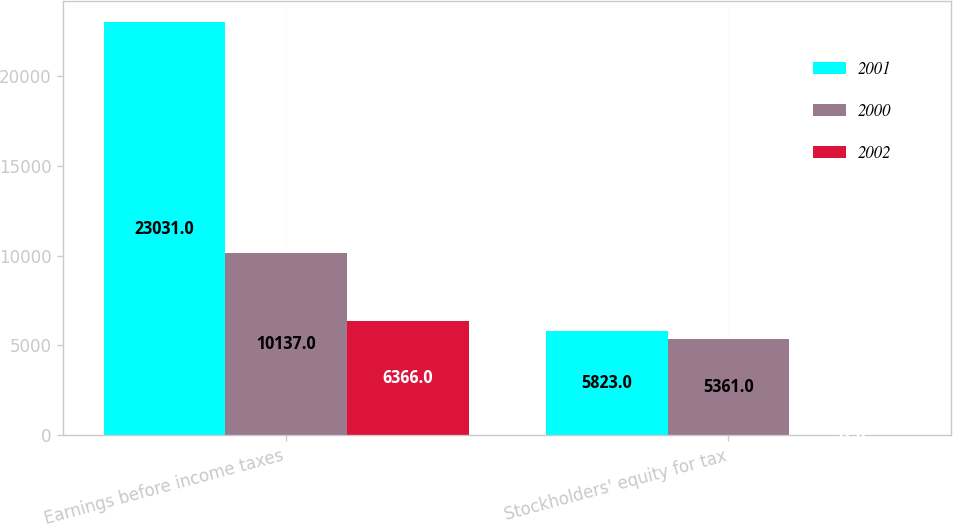Convert chart. <chart><loc_0><loc_0><loc_500><loc_500><stacked_bar_chart><ecel><fcel>Earnings before income taxes<fcel>Stockholders' equity for tax<nl><fcel>2001<fcel>23031<fcel>5823<nl><fcel>2000<fcel>10137<fcel>5361<nl><fcel>2002<fcel>6366<fcel>31<nl></chart> 